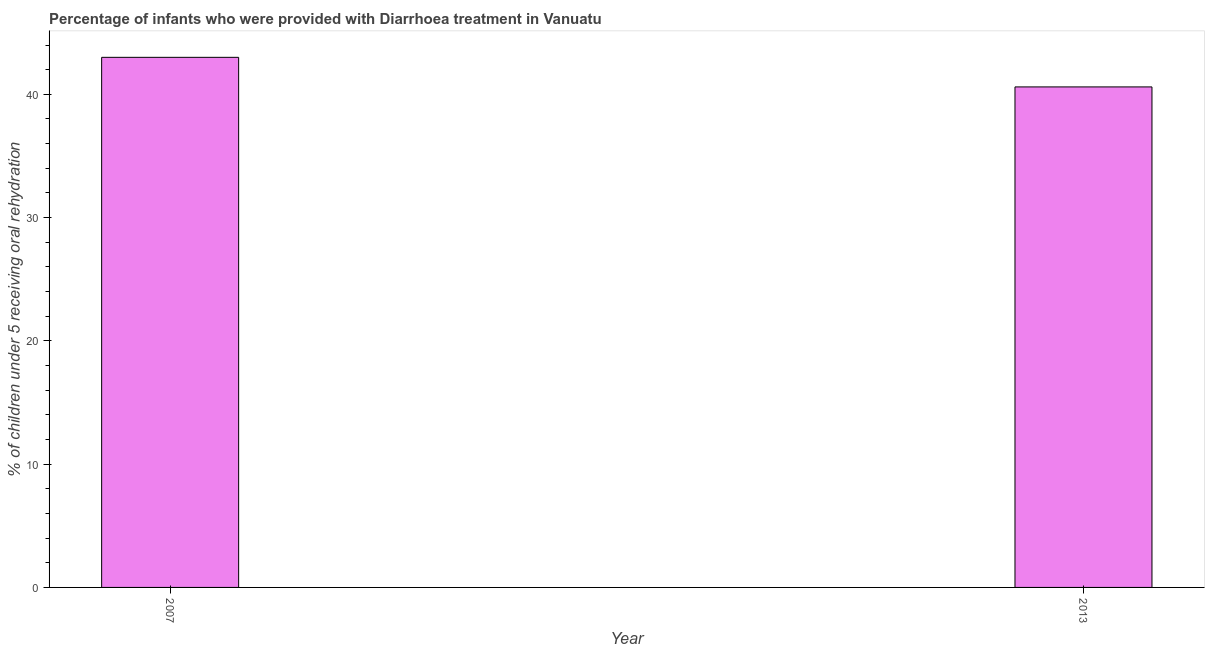Does the graph contain grids?
Your response must be concise. No. What is the title of the graph?
Ensure brevity in your answer.  Percentage of infants who were provided with Diarrhoea treatment in Vanuatu. What is the label or title of the X-axis?
Your response must be concise. Year. What is the label or title of the Y-axis?
Keep it short and to the point. % of children under 5 receiving oral rehydration. What is the percentage of children who were provided with treatment diarrhoea in 2013?
Give a very brief answer. 40.6. Across all years, what is the minimum percentage of children who were provided with treatment diarrhoea?
Provide a short and direct response. 40.6. In which year was the percentage of children who were provided with treatment diarrhoea minimum?
Make the answer very short. 2013. What is the sum of the percentage of children who were provided with treatment diarrhoea?
Give a very brief answer. 83.6. What is the difference between the percentage of children who were provided with treatment diarrhoea in 2007 and 2013?
Offer a very short reply. 2.4. What is the average percentage of children who were provided with treatment diarrhoea per year?
Your answer should be compact. 41.8. What is the median percentage of children who were provided with treatment diarrhoea?
Keep it short and to the point. 41.8. In how many years, is the percentage of children who were provided with treatment diarrhoea greater than 22 %?
Provide a short and direct response. 2. What is the ratio of the percentage of children who were provided with treatment diarrhoea in 2007 to that in 2013?
Provide a short and direct response. 1.06. What is the difference between two consecutive major ticks on the Y-axis?
Your response must be concise. 10. Are the values on the major ticks of Y-axis written in scientific E-notation?
Give a very brief answer. No. What is the % of children under 5 receiving oral rehydration of 2013?
Your answer should be compact. 40.6. What is the difference between the % of children under 5 receiving oral rehydration in 2007 and 2013?
Make the answer very short. 2.4. What is the ratio of the % of children under 5 receiving oral rehydration in 2007 to that in 2013?
Make the answer very short. 1.06. 